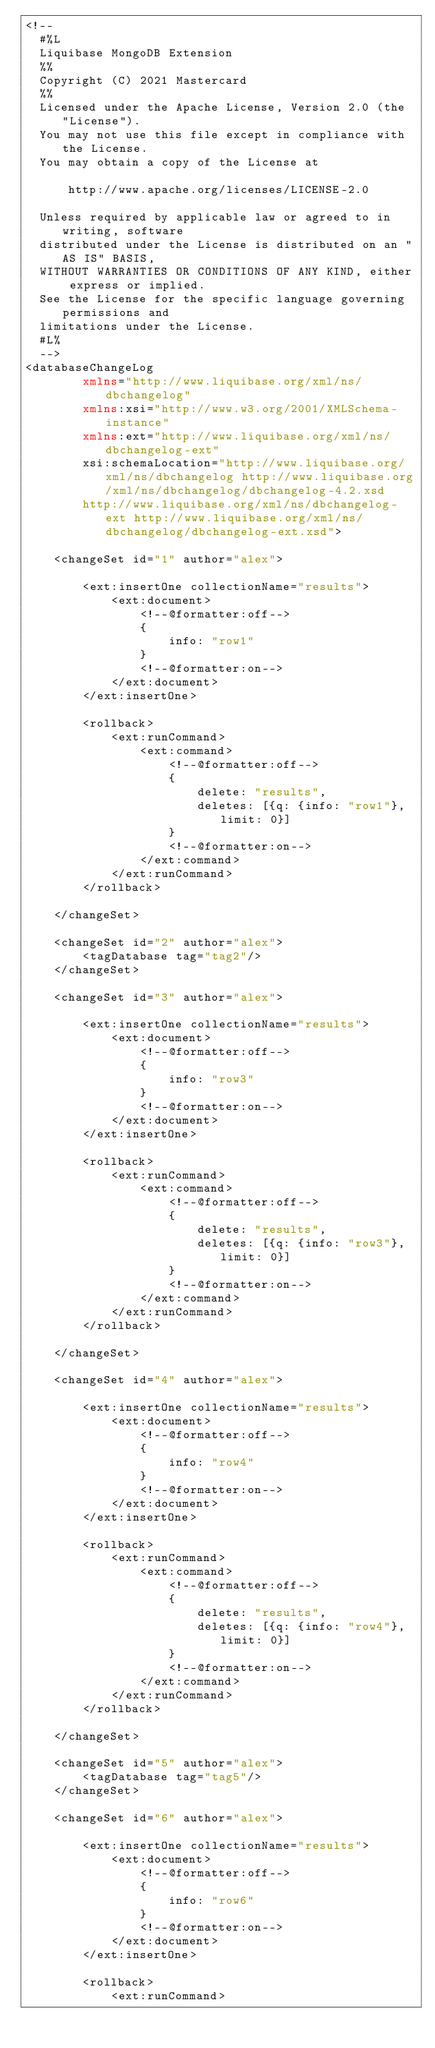Convert code to text. <code><loc_0><loc_0><loc_500><loc_500><_XML_><!--
  #%L
  Liquibase MongoDB Extension
  %%
  Copyright (C) 2021 Mastercard
  %%
  Licensed under the Apache License, Version 2.0 (the "License").
  You may not use this file except in compliance with the License.
  You may obtain a copy of the License at

      http://www.apache.org/licenses/LICENSE-2.0

  Unless required by applicable law or agreed to in writing, software
  distributed under the License is distributed on an "AS IS" BASIS,
  WITHOUT WARRANTIES OR CONDITIONS OF ANY KIND, either express or implied.
  See the License for the specific language governing permissions and
  limitations under the License.
  #L%
  -->
<databaseChangeLog
        xmlns="http://www.liquibase.org/xml/ns/dbchangelog"
        xmlns:xsi="http://www.w3.org/2001/XMLSchema-instance"
        xmlns:ext="http://www.liquibase.org/xml/ns/dbchangelog-ext"
        xsi:schemaLocation="http://www.liquibase.org/xml/ns/dbchangelog http://www.liquibase.org/xml/ns/dbchangelog/dbchangelog-4.2.xsd
        http://www.liquibase.org/xml/ns/dbchangelog-ext http://www.liquibase.org/xml/ns/dbchangelog/dbchangelog-ext.xsd">

    <changeSet id="1" author="alex">

        <ext:insertOne collectionName="results">
            <ext:document>
                <!--@formatter:off-->
                {
                    info: "row1"
                }
                <!--@formatter:on-->
            </ext:document>
        </ext:insertOne>

        <rollback>
            <ext:runCommand>
                <ext:command>
                    <!--@formatter:off-->
                    {
                        delete: "results",
                        deletes: [{q: {info: "row1"}, limit: 0}]
                    }
                    <!--@formatter:on-->
                </ext:command>
            </ext:runCommand>
        </rollback>

    </changeSet>

    <changeSet id="2" author="alex">
        <tagDatabase tag="tag2"/>
    </changeSet>

    <changeSet id="3" author="alex">

        <ext:insertOne collectionName="results">
            <ext:document>
                <!--@formatter:off-->
                {
                    info: "row3"
                }
                <!--@formatter:on-->
            </ext:document>
        </ext:insertOne>

        <rollback>
            <ext:runCommand>
                <ext:command>
                    <!--@formatter:off-->
                    {
                        delete: "results",
                        deletes: [{q: {info: "row3"}, limit: 0}]
                    }
                    <!--@formatter:on-->
                </ext:command>
            </ext:runCommand>
        </rollback>

    </changeSet>

    <changeSet id="4" author="alex">

        <ext:insertOne collectionName="results">
            <ext:document>
                <!--@formatter:off-->
                {
                    info: "row4"
                }
                <!--@formatter:on-->
            </ext:document>
        </ext:insertOne>

        <rollback>
            <ext:runCommand>
                <ext:command>
                    <!--@formatter:off-->
                    {
                        delete: "results",
                        deletes: [{q: {info: "row4"}, limit: 0}]
                    }
                    <!--@formatter:on-->
                </ext:command>
            </ext:runCommand>
        </rollback>

    </changeSet>

    <changeSet id="5" author="alex">
        <tagDatabase tag="tag5"/>
    </changeSet>

    <changeSet id="6" author="alex">

        <ext:insertOne collectionName="results">
            <ext:document>
                <!--@formatter:off-->
                {
                    info: "row6"
                }
                <!--@formatter:on-->
            </ext:document>
        </ext:insertOne>

        <rollback>
            <ext:runCommand></code> 